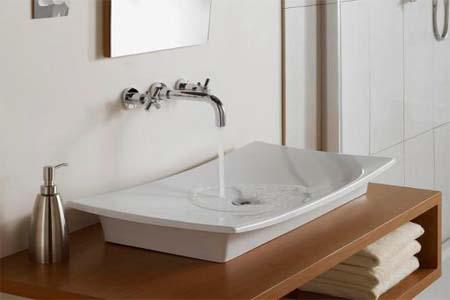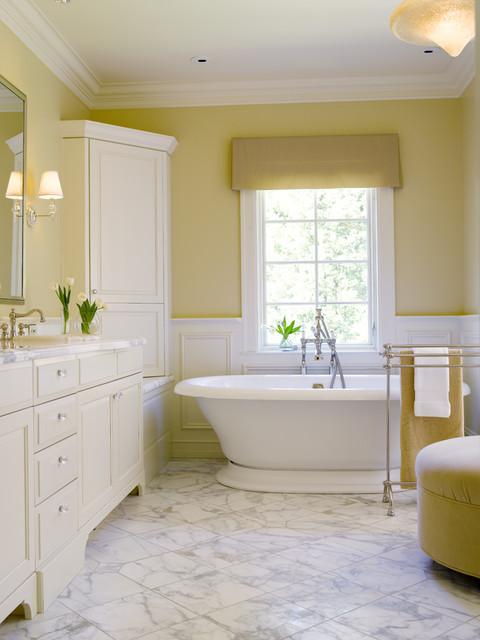The first image is the image on the left, the second image is the image on the right. Assess this claim about the two images: "Exactly one bathroom vanity unit is wrapped around a wall.". Correct or not? Answer yes or no. No. The first image is the image on the left, the second image is the image on the right. Analyze the images presented: Is the assertion "Both images have different wall colors and there is a stand alone bath tub in one of them." valid? Answer yes or no. Yes. 